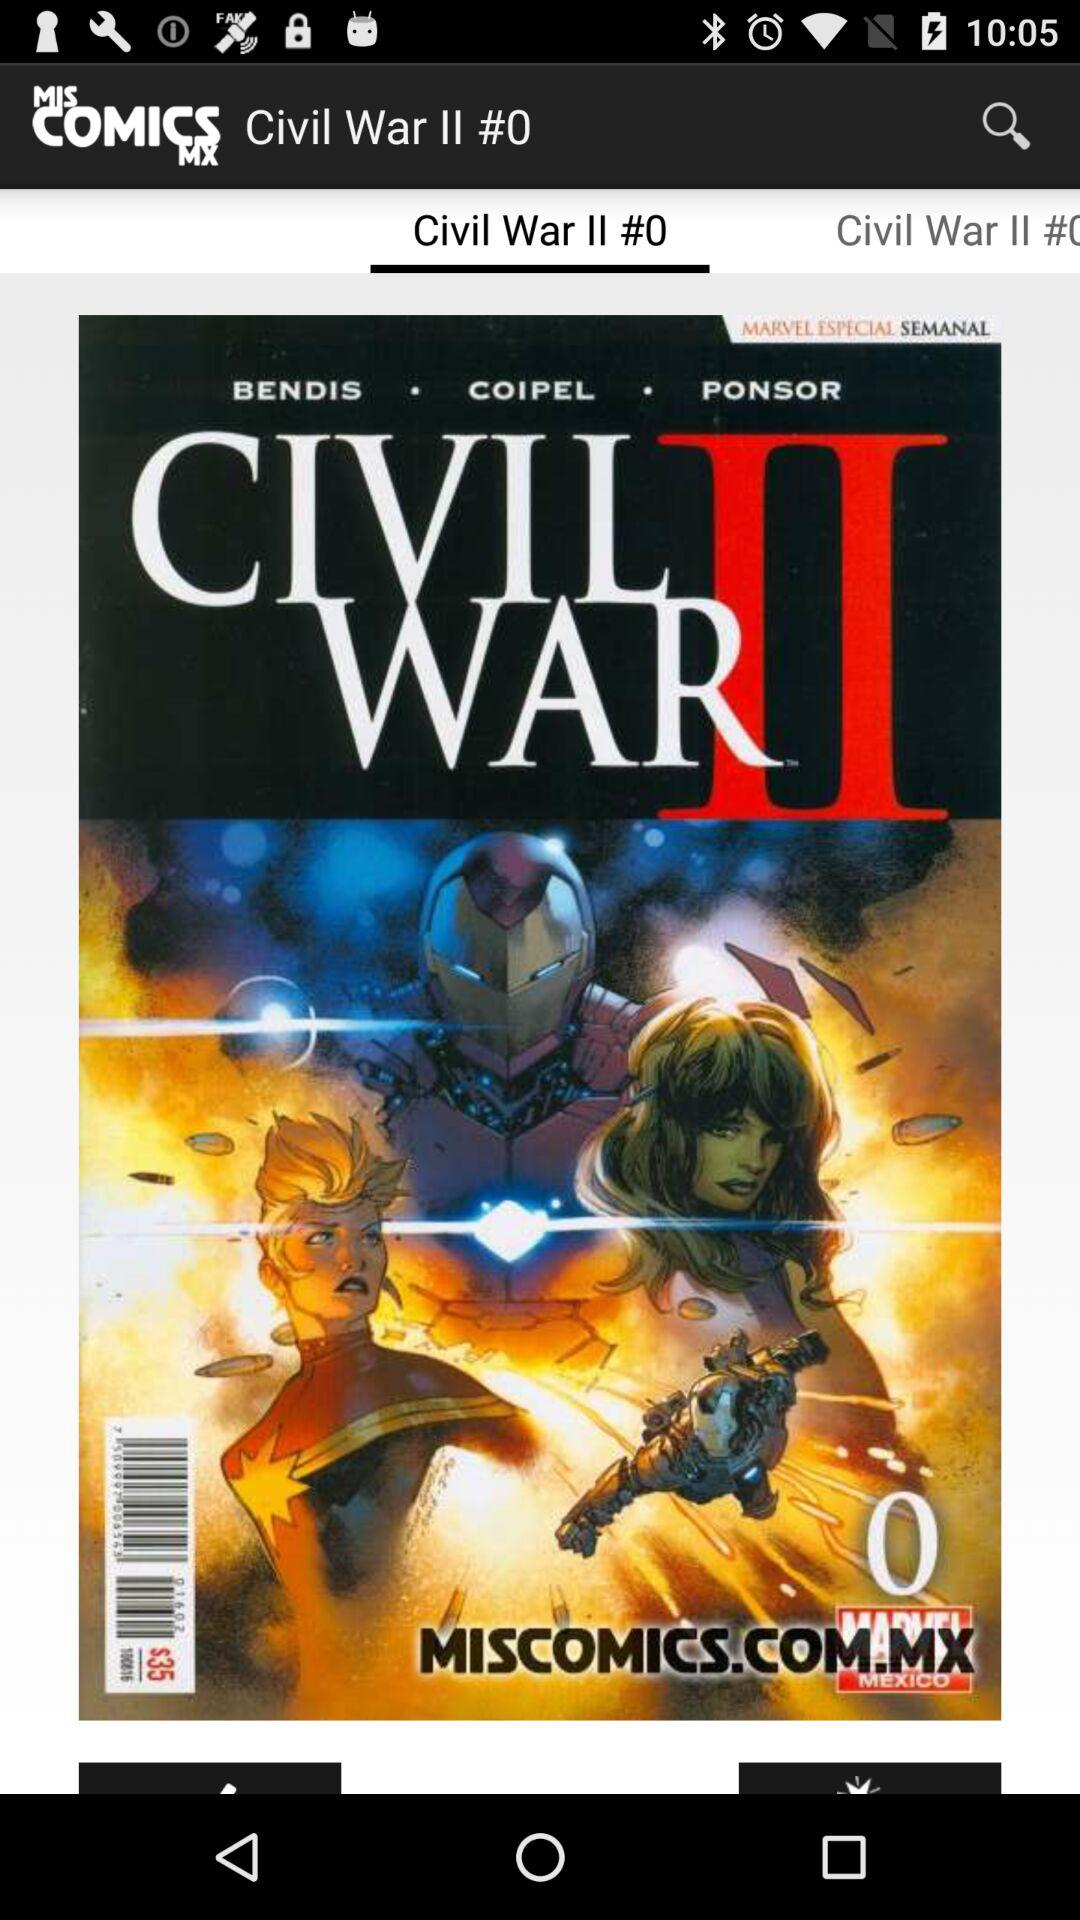What is the app name? The app name is "MIS COMICS MX". 